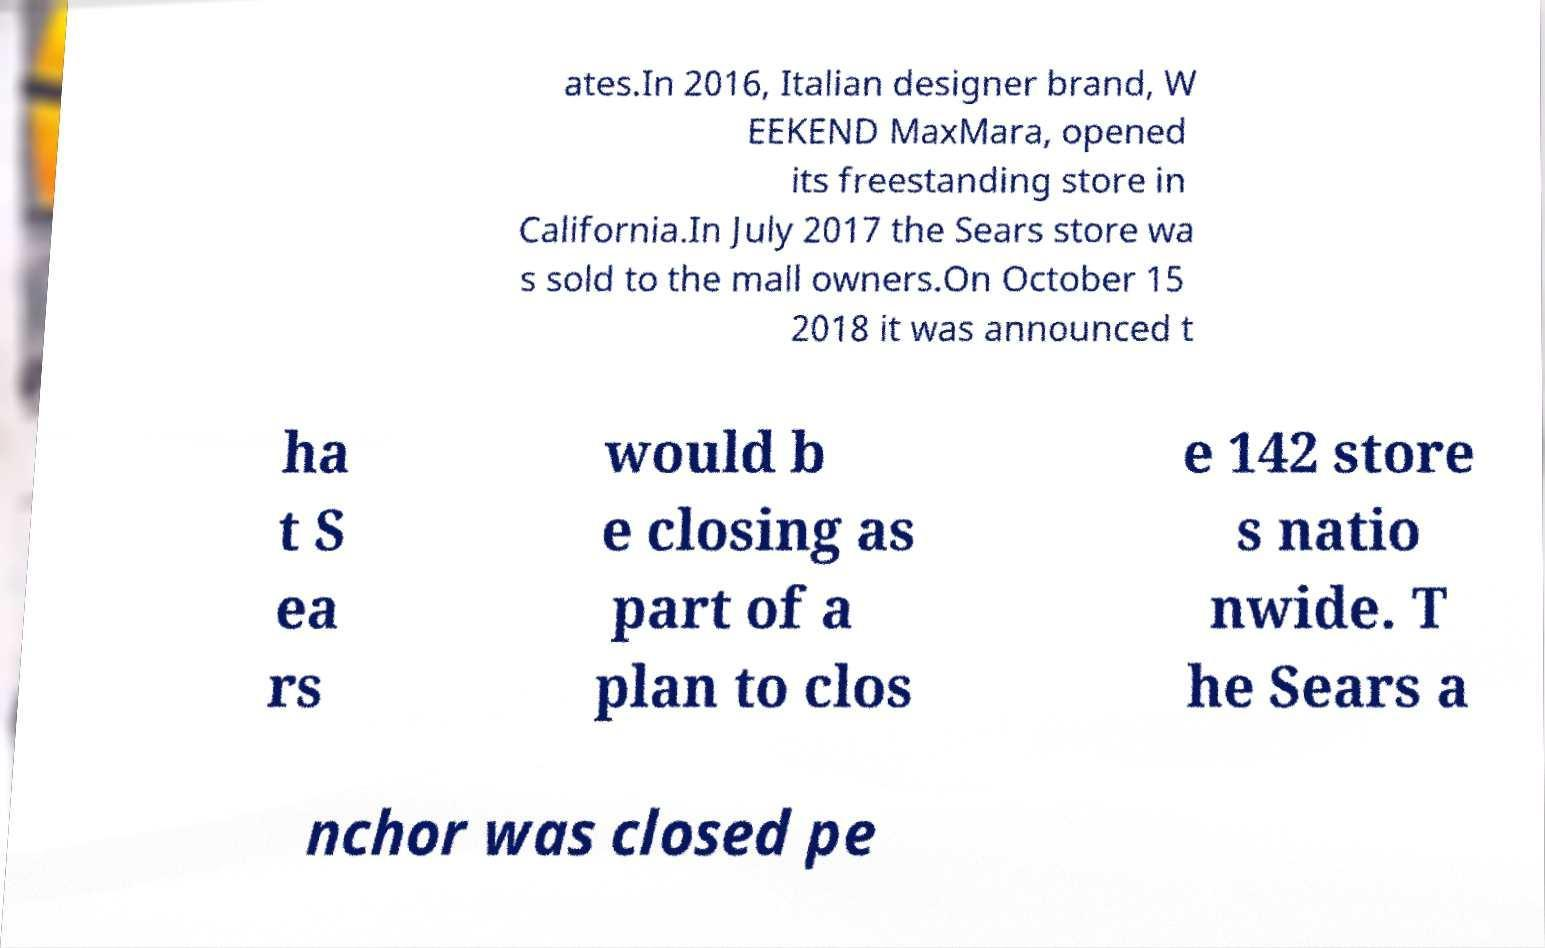There's text embedded in this image that I need extracted. Can you transcribe it verbatim? ates.In 2016, Italian designer brand, W EEKEND MaxMara, opened its freestanding store in California.In July 2017 the Sears store wa s sold to the mall owners.On October 15 2018 it was announced t ha t S ea rs would b e closing as part of a plan to clos e 142 store s natio nwide. T he Sears a nchor was closed pe 